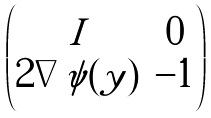<formula> <loc_0><loc_0><loc_500><loc_500>\begin{pmatrix} I & 0 \\ 2 \nabla \psi ( y ) & - 1 \end{pmatrix}</formula> 